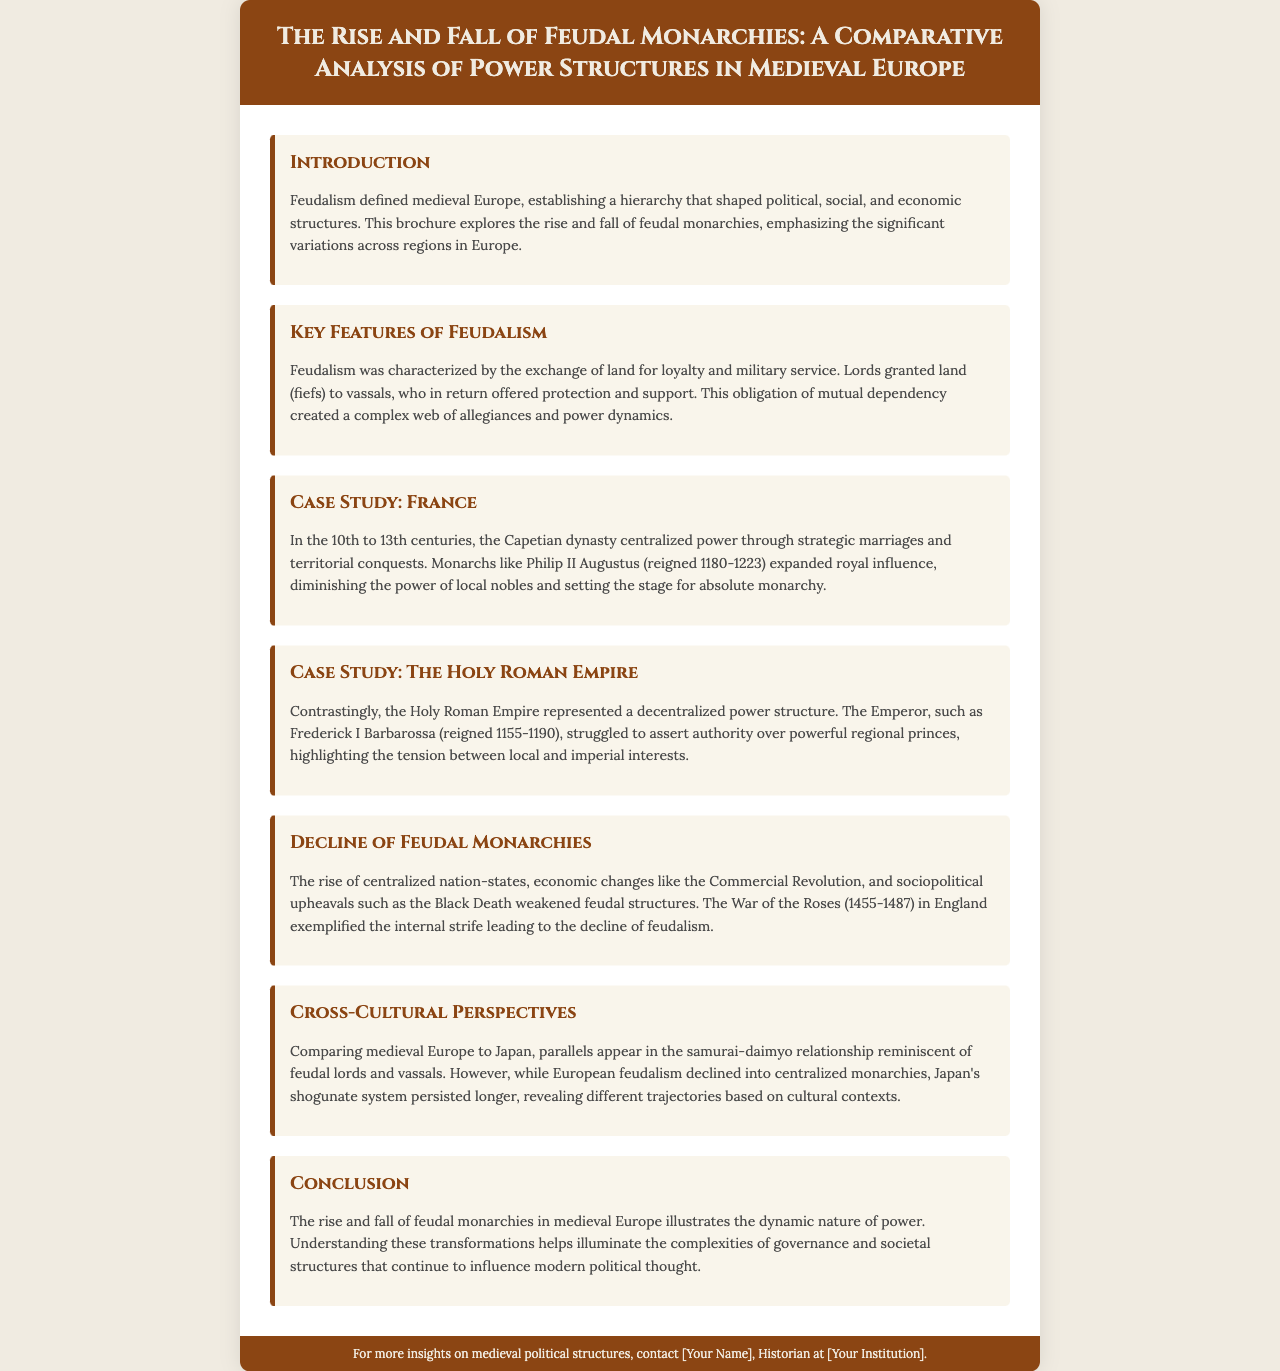What was the primary defining structure of medieval Europe? The document states that feudalism defined medieval Europe, establishing a hierarchy that shaped political, social, and economic structures.
Answer: Feudalism Who was the monarch that expanded royal influence in France during the 10th to 13th centuries? Philip II Augustus is mentioned as a key figure who centralized power in France during this period.
Answer: Philip II Augustus What major event exemplified the internal strife leading to the decline of feudalism in England? The document specifically mentions the War of the Roses as an example of internal strife impacting feudalism.
Answer: War of the Roses What relationship in Japan is compared to European feudal lords and vassals? The document references the samurai-daimyo relationship as a parallel to European feudal structures.
Answer: Samurai-daimyo Which empire experienced a struggle for authority between the Emperor and regional princes? The Holy Roman Empire is the empire highlighted for its decentralized power structure and tension between the Emperor and regional princes.
Answer: The Holy Roman Empire What system in Japan persisted longer than European feudalism according to the document? The shogunate system is mentioned as having persisted longer than feudalism in Europe.
Answer: Shogunate system What were the significant economic changes contributing to the decline of feudal structures? The document indicates that the Commercial Revolution was one of the economic changes contributing to this decline.
Answer: Commercial Revolution Which sociopolitical upheaval is mentioned in the brochure as weaken the feudal structures? The Black Death is explicitly cited as a sociopolitical upheaval that weakened feudal structures.
Answer: Black Death In what regions does the brochure emphasize variations in feudal monarchies? The document explores variations across regions in Europe regarding feudal monarchies.
Answer: Regions in Europe 